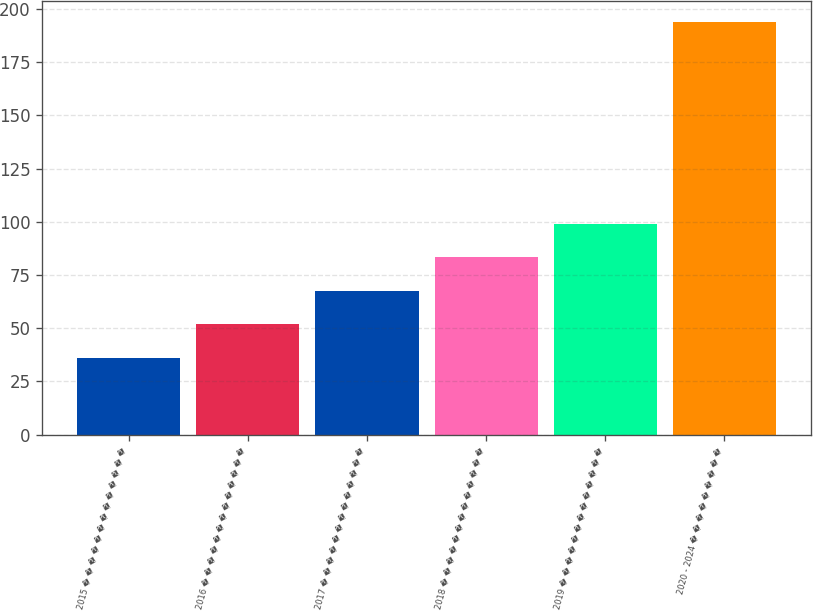Convert chart to OTSL. <chart><loc_0><loc_0><loc_500><loc_500><bar_chart><fcel>2015 � � � � � � � � � � � � �<fcel>2016 � � � � � � � � � � � � �<fcel>2017 � � � � � � � � � � � � �<fcel>2018 � � � � � � � � � � � � �<fcel>2019 � � � � � � � � � � � � �<fcel>2020 - 2024 � � � � � � � � �<nl><fcel>36<fcel>51.8<fcel>67.6<fcel>83.4<fcel>99.2<fcel>194<nl></chart> 